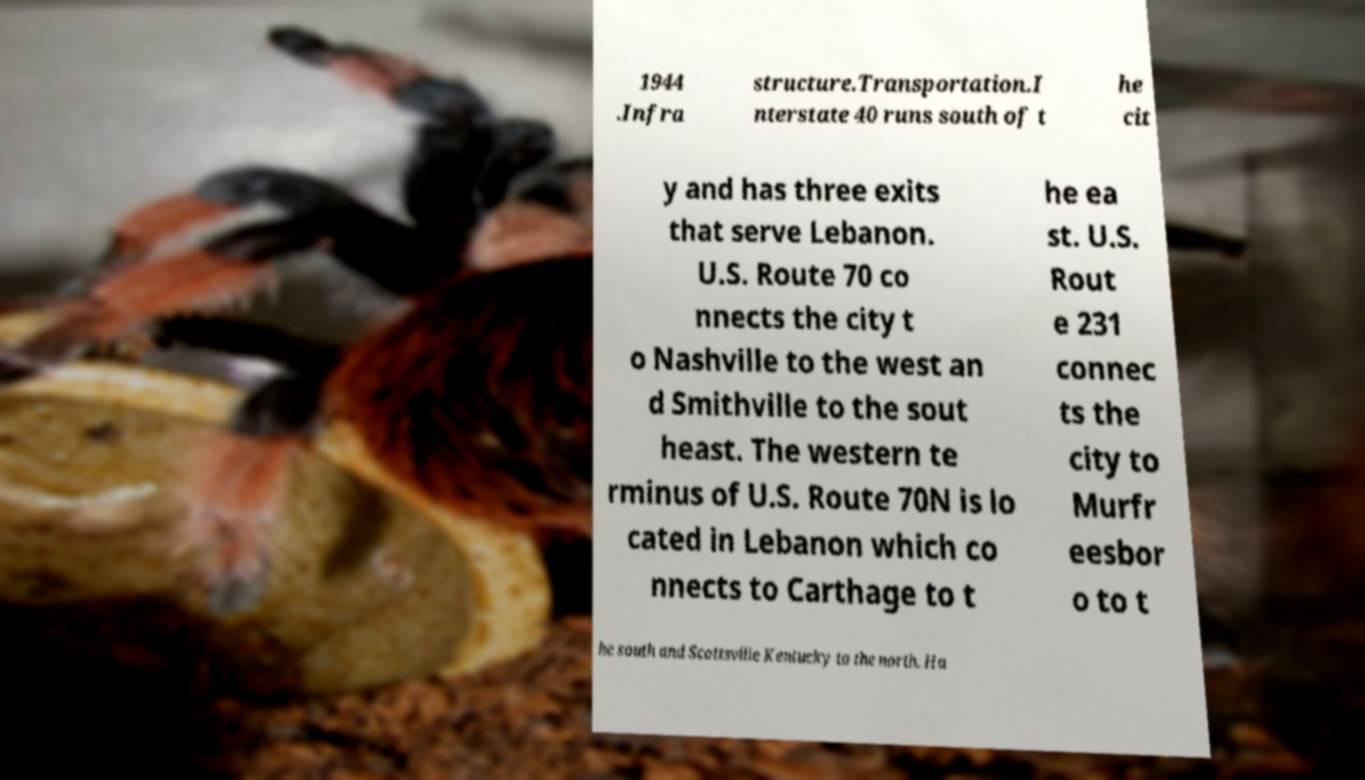Please identify and transcribe the text found in this image. 1944 .Infra structure.Transportation.I nterstate 40 runs south of t he cit y and has three exits that serve Lebanon. U.S. Route 70 co nnects the city t o Nashville to the west an d Smithville to the sout heast. The western te rminus of U.S. Route 70N is lo cated in Lebanon which co nnects to Carthage to t he ea st. U.S. Rout e 231 connec ts the city to Murfr eesbor o to t he south and Scottsville Kentucky to the north. Ha 